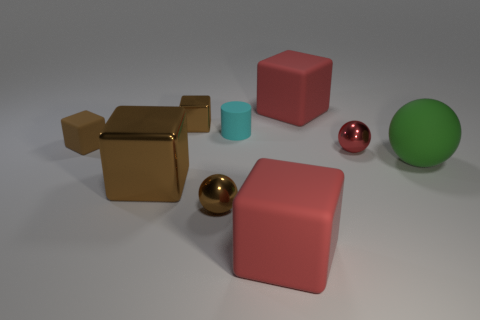What shape is the small metal thing to the right of the matte cylinder to the left of the large red matte block in front of the green rubber object?
Provide a short and direct response. Sphere. What is the shape of the small metallic thing that is the same color as the small shiny cube?
Provide a succinct answer. Sphere. Is the size of the brown sphere the same as the metal block that is behind the large brown thing?
Offer a very short reply. Yes. Are there any big green rubber balls that are left of the big rubber thing behind the red ball?
Your response must be concise. No. There is a cube that is to the right of the small brown metallic sphere and behind the cyan rubber object; what material is it?
Your response must be concise. Rubber. What is the color of the rubber thing that is to the left of the small brown metal object left of the tiny sphere to the left of the rubber cylinder?
Provide a short and direct response. Brown. What color is the matte block that is the same size as the red metallic ball?
Provide a succinct answer. Brown. Does the tiny cylinder have the same color as the metallic cube that is in front of the green ball?
Offer a very short reply. No. What material is the tiny object on the left side of the brown block behind the tiny cyan rubber cylinder?
Make the answer very short. Rubber. How many metal spheres are both on the left side of the cylinder and behind the green rubber sphere?
Offer a very short reply. 0. 